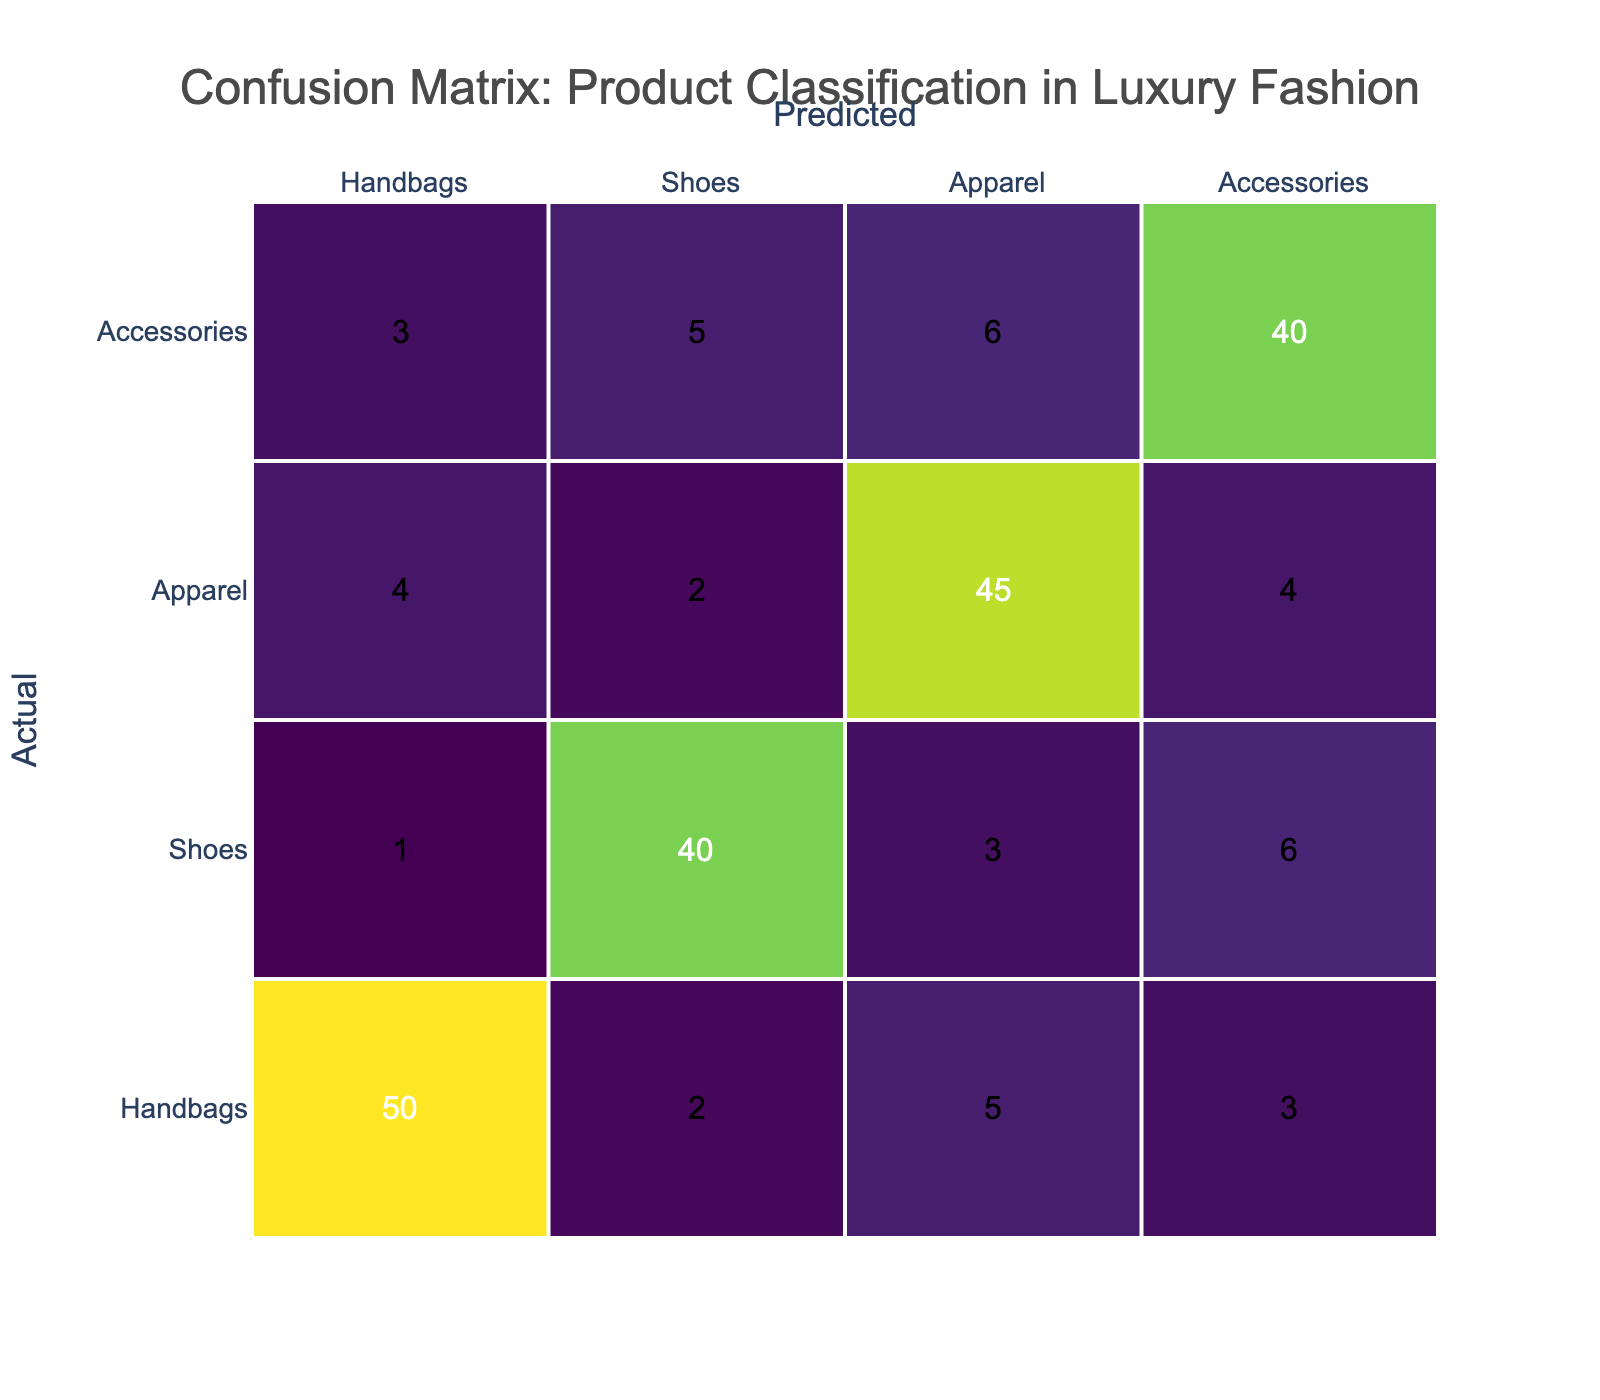What is the total number of Handbags predicted correctly? According to the table, the value for Handbags predicted as Handbags is 50. This represents the correct predictions.
Answer: 50 How many times were Shoes incorrectly predicted as Handbags? The table shows that 1 pair of Shoes was predicted incorrectly as Handbags.
Answer: 1 What is the sum of Accessories predicted as other categories? To find this, we look at the Accessories row: 3 (Handbags) + 5 (Shoes) + 6 (Apparel) = 14.
Answer: 14 Was Apparel ever predicted more than 50 times in any category? According to the table, the maximum value in the Apparel row is 45 (predicted correctly as Apparel), so it was never predicted more than 50 times.
Answer: No What percentage of the total actual Handbags were predicted correctly? The total actual Handbags is 50 + 2 + 5 + 3 = 60. The correct Handbags prediction is 50. The percentage is (50/60) * 100 = 83.33%.
Answer: 83.33% How many total instances of Shoes were predicted across all categories? We total the values from the Shoes row: 1 (Handbags) + 40 (Shoes) + 3 (Apparel) + 6 (Accessories) = 50.
Answer: 50 Which product category had the highest number of correct predictions? The highest value in the diagonal of the confusion matrix belongs to Handbags with a value of 50, which is higher than the other categories.
Answer: Handbags What is the average number of misclassifications for all categories? The misclassifications for all categories are: Handbags = 2 + 5 + 3 = 10, Shoes = 1 + 3 + 6 = 10, Apparel = 4 + 2 + 4 = 10, Accessories = 3 + 5 + 6 = 14. The total misclassifications = 10 + 10 + 10 + 14 = 44. The average is 44/4 = 11.
Answer: 11 What is the difference in the number of correct predictions between Shoes and Apparel? The number of correct predictions for Shoes is 40 and for Apparel, it is 45. Thus, the difference is 45 - 40 = 5.
Answer: 5 How many total predictions are made for Accessories? In the Accessories row, the total is calculated as follows: 3 (Handbags) + 5 (Shoes) + 6 (Apparel) + 40 (Accessories) = 54.
Answer: 54 